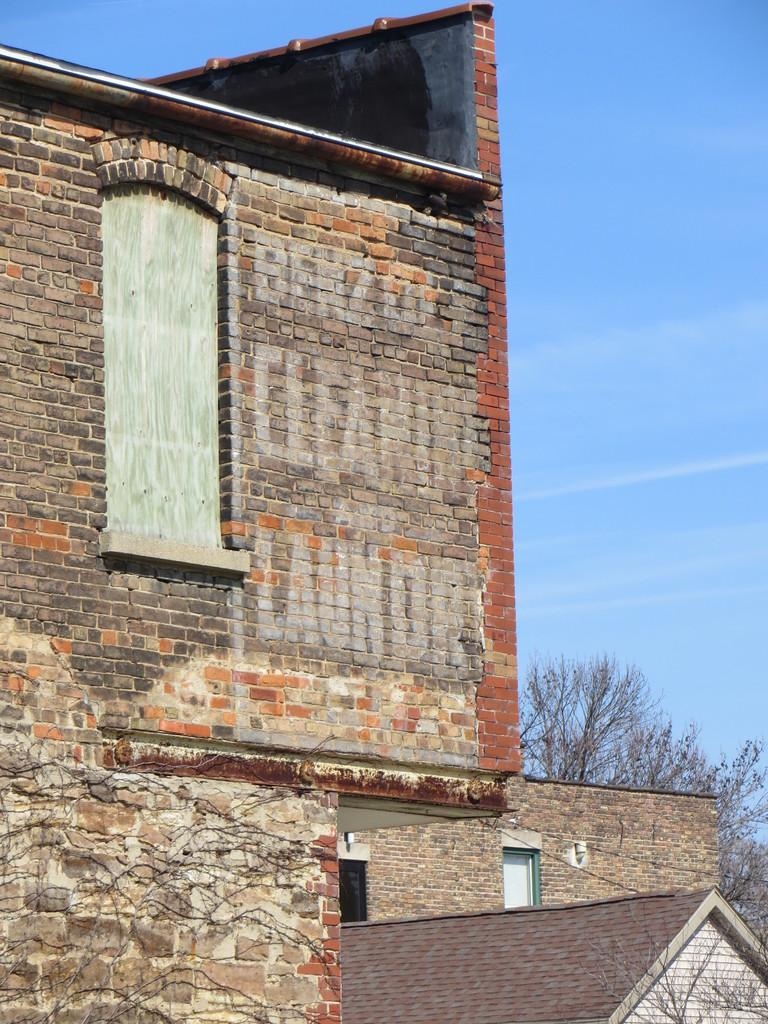What type of structures can be seen in the image? There are buildings in the image. What other natural elements are present in the image? There are trees in the image. What architectural features can be observed on the buildings? There are windows and a door visible in the image. What can be seen in the background of the image? The sky is visible in the background of the image. What type of lumber is being used to construct the buildings in the image? There is no specific information about the type of lumber used in the construction of the buildings in the image. 